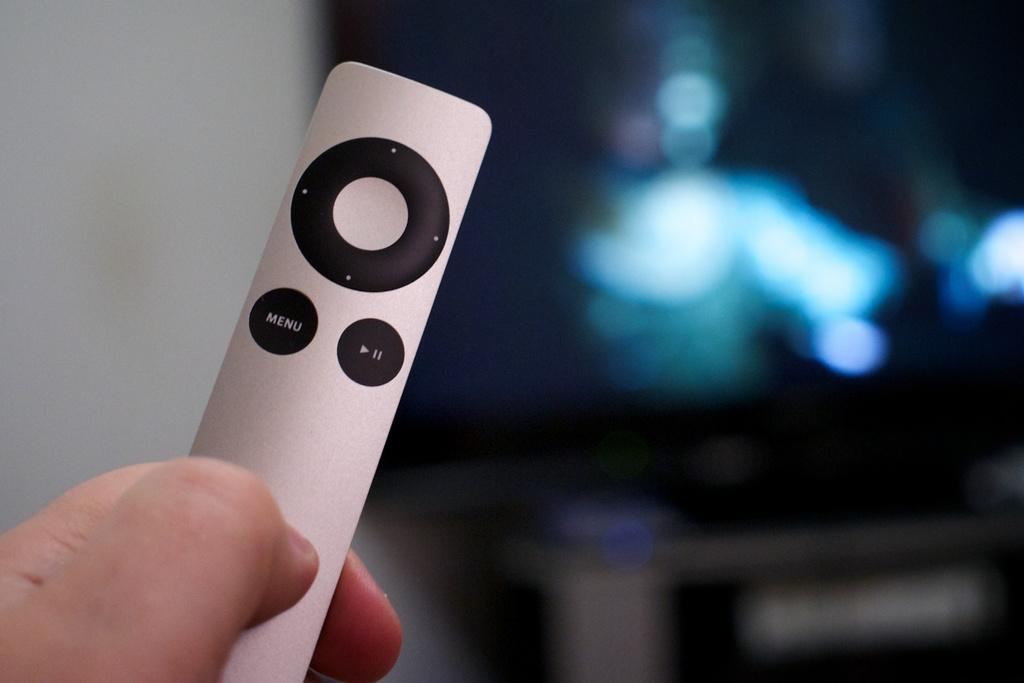<image>
Present a compact description of the photo's key features. A person holding a remote with a menu button on it. 